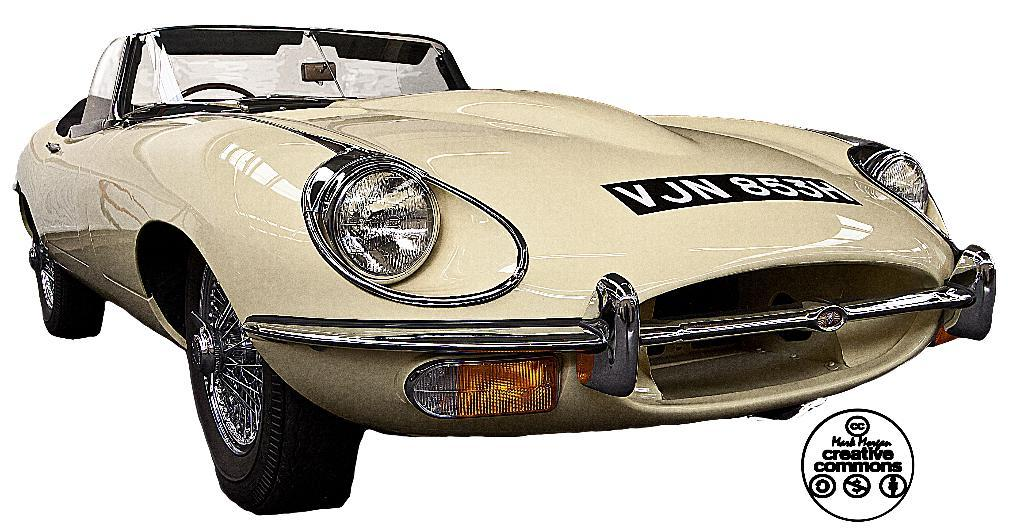What is the main subject of the image? The main subject of the image is a car. What specific features can be seen on the car? The car has a group of headlights, a bumper, mirrors, and a set of indicators. What type of flowers are growing on the car in the image? There are no flowers growing on the car in the image; it is a car with specific features like headlights, bumper, mirrors, and indicators. What songs can be heard playing from the car in the image? There is no audio information provided in the image, so it is not possible to determine what songs might be playing. 